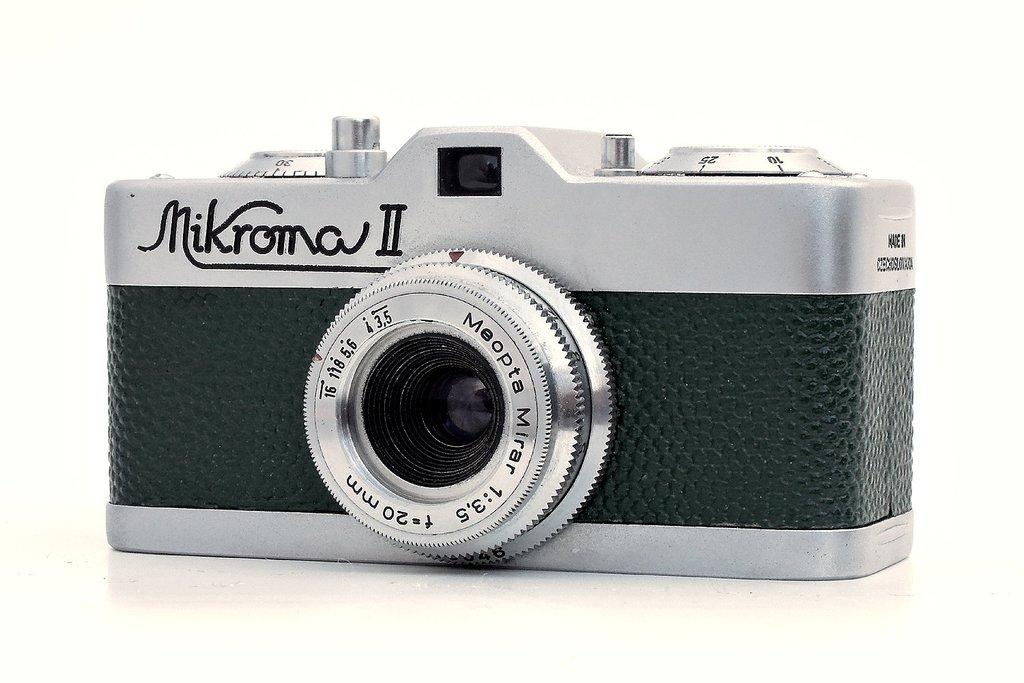What object is the main subject of the image? There is a camera in the image. What colors are used in the design of the camera? The camera has a gray and black color combination. Where is the camera placed in the image? The camera is placed on a white color floor. What is the color of the background in the image? The background of the image is white in color. Are there any plants in the image? There is no mention of plants in the provided facts, so we cannot determine if there are any plants in the image. What type of creature can be seen interacting with the camera in the image? There is no creature present in the image; it only features a camera placed on a white floor with a white background. 